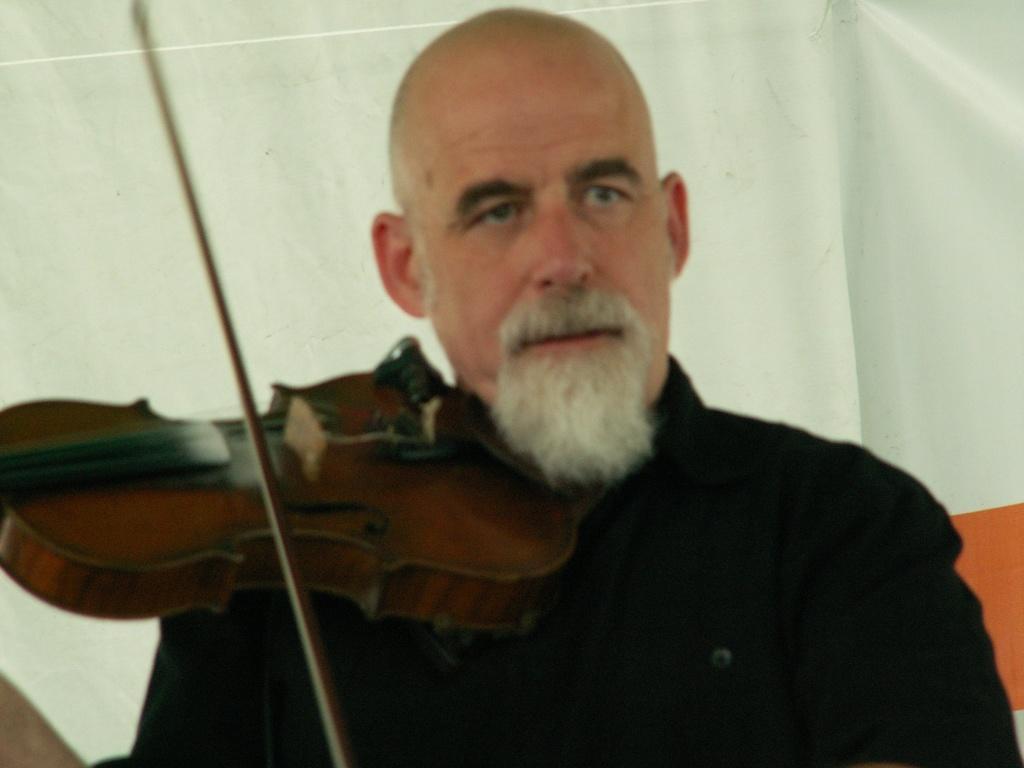Describe this image in one or two sentences. In this image we can see a man holding a violin in his hands. We can see a banner in the background. 